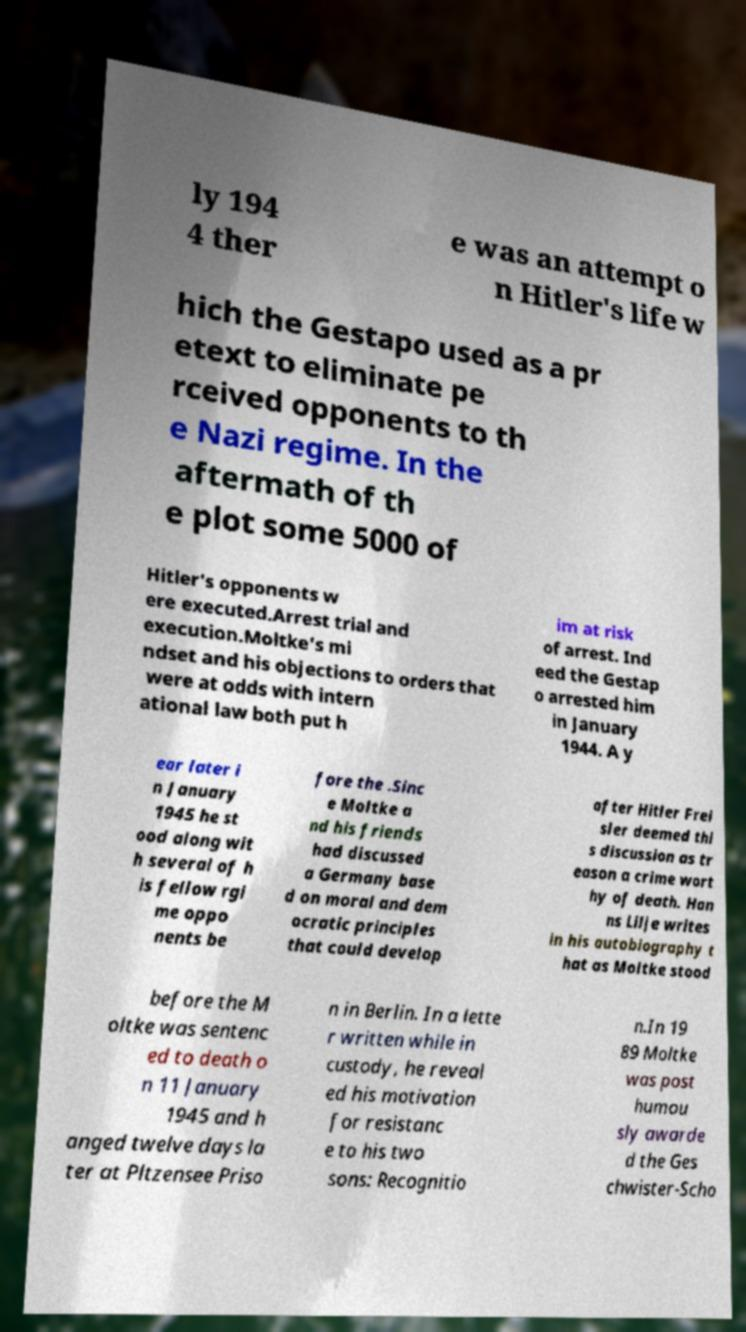Please identify and transcribe the text found in this image. ly 194 4 ther e was an attempt o n Hitler's life w hich the Gestapo used as a pr etext to eliminate pe rceived opponents to th e Nazi regime. In the aftermath of th e plot some 5000 of Hitler's opponents w ere executed.Arrest trial and execution.Moltke's mi ndset and his objections to orders that were at odds with intern ational law both put h im at risk of arrest. Ind eed the Gestap o arrested him in January 1944. A y ear later i n January 1945 he st ood along wit h several of h is fellow rgi me oppo nents be fore the .Sinc e Moltke a nd his friends had discussed a Germany base d on moral and dem ocratic principles that could develop after Hitler Frei sler deemed thi s discussion as tr eason a crime wort hy of death. Han ns Lilje writes in his autobiography t hat as Moltke stood before the M oltke was sentenc ed to death o n 11 January 1945 and h anged twelve days la ter at Pltzensee Priso n in Berlin. In a lette r written while in custody, he reveal ed his motivation for resistanc e to his two sons: Recognitio n.In 19 89 Moltke was post humou sly awarde d the Ges chwister-Scho 